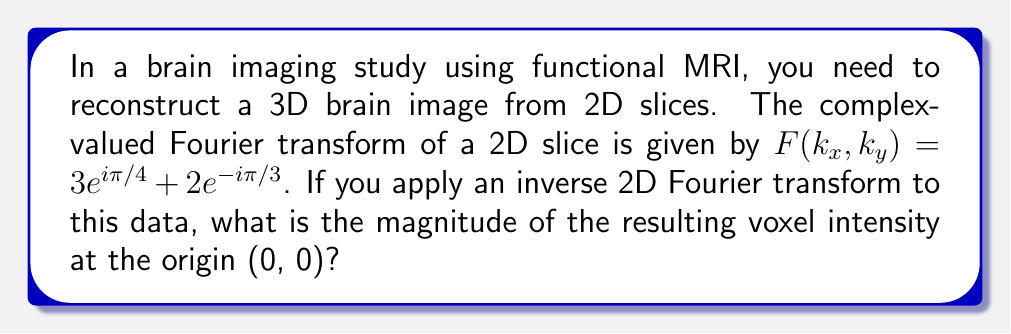Can you answer this question? To solve this problem, we'll follow these steps:

1) The inverse Fourier transform at the origin (0, 0) is equal to the average value of the Fourier transform. This is a property of Fourier transforms.

2) Therefore, we need to calculate the average of $F(k_x, k_y)$:

   $$F(k_x, k_y) = 3e^{i\pi/4} + 2e^{-i\pi/3}$$

3) To find the magnitude of this complex number, we need to calculate its absolute value:

   $$|F(k_x, k_y)| = |3e^{i\pi/4} + 2e^{-i\pi/3}|$$

4) We can represent these complex numbers in rectangular form:
   
   $3e^{i\pi/4} = 3(\cos(\pi/4) + i\sin(\pi/4)) = 3(\frac{\sqrt{2}}{2} + i\frac{\sqrt{2}}{2})$
   
   $2e^{-i\pi/3} = 2(\cos(-\pi/3) + i\sin(-\pi/3)) = 2(\frac{1}{2} - i\frac{\sqrt{3}}{2})$

5) Adding these:

   $F(k_x, k_y) = (3\frac{\sqrt{2}}{2} + 1) + i(3\frac{\sqrt{2}}{2} - \sqrt{3})$

6) The magnitude is the square root of the sum of squares of real and imaginary parts:

   $|F(k_x, k_y)| = \sqrt{(3\frac{\sqrt{2}}{2} + 1)^2 + (3\frac{\sqrt{2}}{2} - \sqrt{3})^2}$

7) Simplifying:

   $|F(k_x, k_y)| = \sqrt{(\frac{3\sqrt{2}}{2} + 1)^2 + (\frac{3\sqrt{2}}{2} - \sqrt{3})^2}$
   
   $= \sqrt{(\frac{9}{2} + 3\sqrt{2} + 1) + (\frac{9}{2} - 3\sqrt{2}\sqrt{3} + 3)}$
   
   $= \sqrt{7 + 3\sqrt{2} - 3\sqrt{2}\sqrt{3}}$
   
   $\approx 2.6458$

This is the magnitude of the voxel intensity at the origin (0, 0) in the reconstructed 3D brain image.
Answer: $\sqrt{7 + 3\sqrt{2} - 3\sqrt{2}\sqrt{3}}$ 